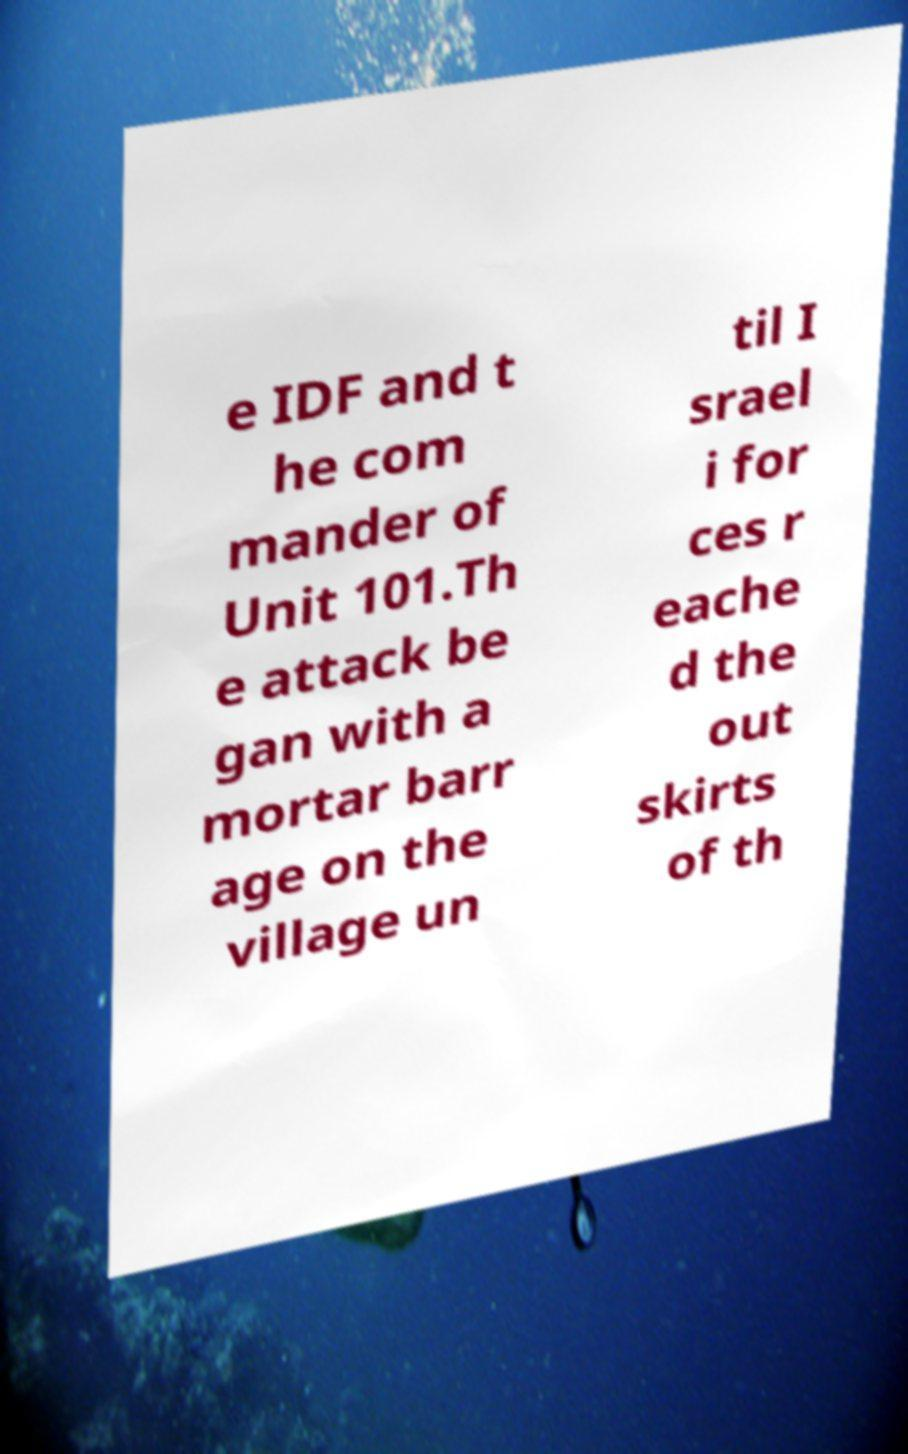Can you accurately transcribe the text from the provided image for me? e IDF and t he com mander of Unit 101.Th e attack be gan with a mortar barr age on the village un til I srael i for ces r eache d the out skirts of th 